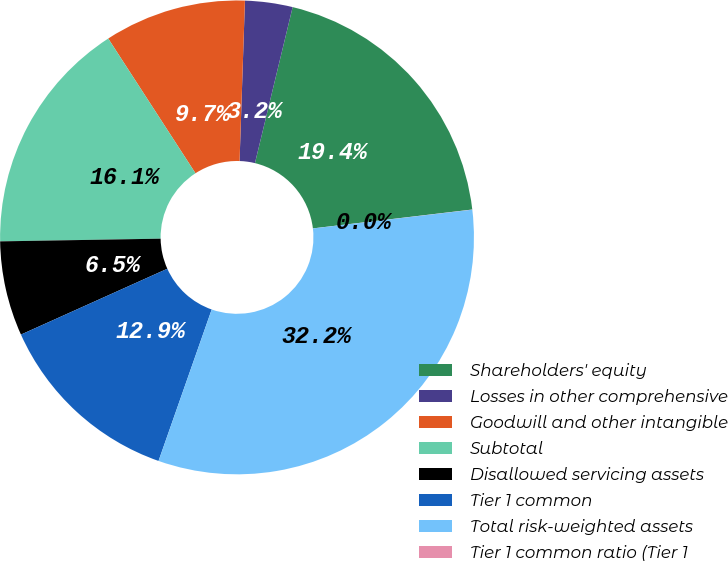<chart> <loc_0><loc_0><loc_500><loc_500><pie_chart><fcel>Shareholders' equity<fcel>Losses in other comprehensive<fcel>Goodwill and other intangible<fcel>Subtotal<fcel>Disallowed servicing assets<fcel>Tier 1 common<fcel>Total risk-weighted assets<fcel>Tier 1 common ratio (Tier 1<nl><fcel>19.35%<fcel>3.24%<fcel>9.68%<fcel>16.12%<fcel>6.46%<fcel>12.9%<fcel>32.24%<fcel>0.01%<nl></chart> 